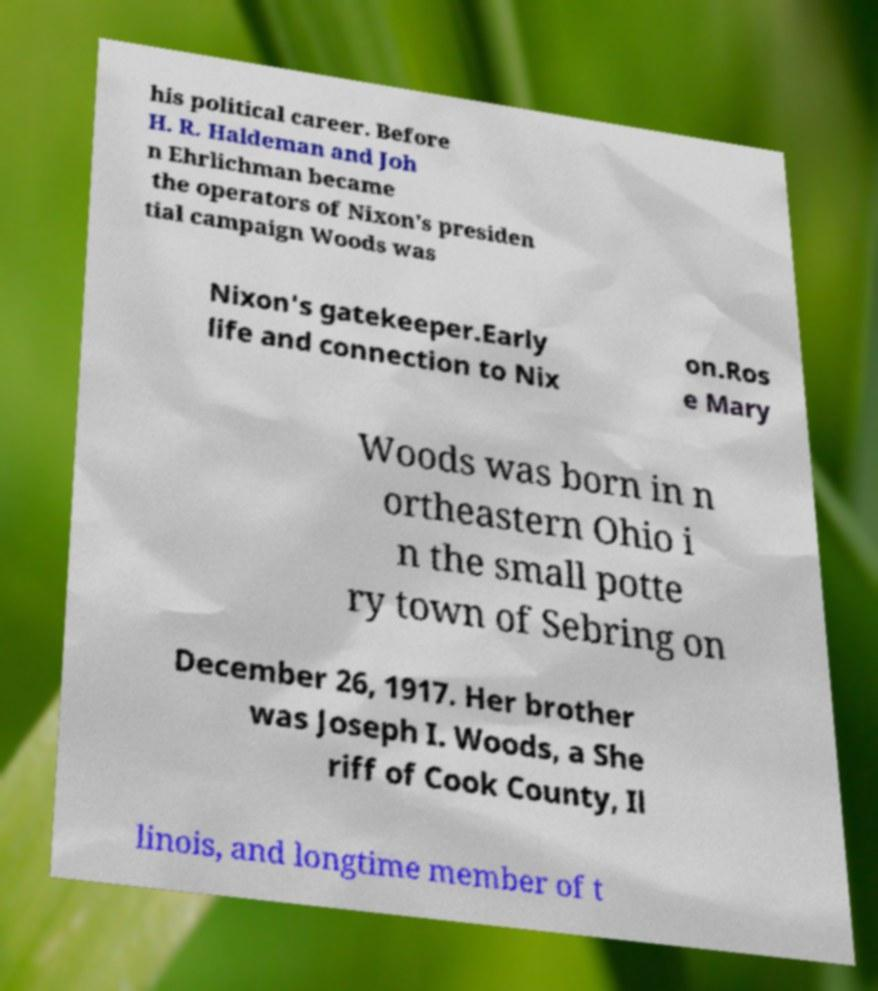Could you assist in decoding the text presented in this image and type it out clearly? his political career. Before H. R. Haldeman and Joh n Ehrlichman became the operators of Nixon's presiden tial campaign Woods was Nixon's gatekeeper.Early life and connection to Nix on.Ros e Mary Woods was born in n ortheastern Ohio i n the small potte ry town of Sebring on December 26, 1917. Her brother was Joseph I. Woods, a She riff of Cook County, Il linois, and longtime member of t 